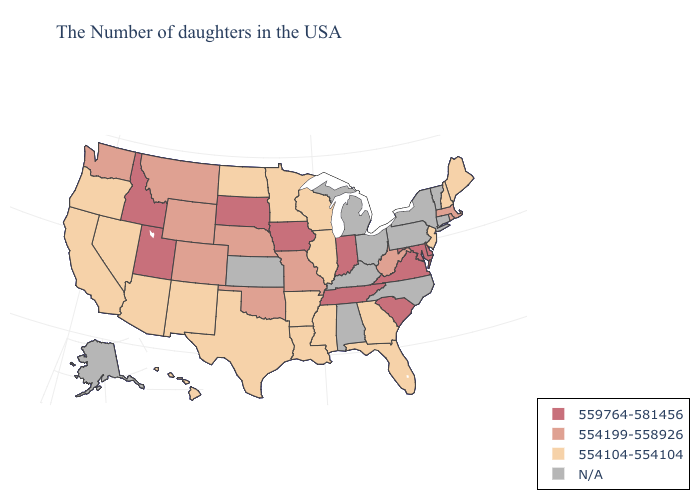Which states have the lowest value in the USA?
Be succinct. Maine, New Hampshire, New Jersey, Florida, Georgia, Wisconsin, Illinois, Mississippi, Louisiana, Arkansas, Minnesota, Texas, North Dakota, New Mexico, Arizona, Nevada, California, Oregon, Hawaii. Which states have the lowest value in the USA?
Quick response, please. Maine, New Hampshire, New Jersey, Florida, Georgia, Wisconsin, Illinois, Mississippi, Louisiana, Arkansas, Minnesota, Texas, North Dakota, New Mexico, Arizona, Nevada, California, Oregon, Hawaii. What is the value of South Dakota?
Keep it brief. 559764-581456. Does New Hampshire have the highest value in the Northeast?
Short answer required. No. Name the states that have a value in the range N/A?
Write a very short answer. Vermont, Connecticut, New York, Pennsylvania, North Carolina, Ohio, Michigan, Kentucky, Alabama, Kansas, Alaska. What is the highest value in states that border Utah?
Write a very short answer. 559764-581456. What is the value of Nebraska?
Concise answer only. 554199-558926. What is the highest value in states that border Connecticut?
Short answer required. 554199-558926. What is the value of North Carolina?
Answer briefly. N/A. Is the legend a continuous bar?
Be succinct. No. What is the value of Hawaii?
Give a very brief answer. 554104-554104. Which states have the lowest value in the West?
Give a very brief answer. New Mexico, Arizona, Nevada, California, Oregon, Hawaii. Name the states that have a value in the range N/A?
Be succinct. Vermont, Connecticut, New York, Pennsylvania, North Carolina, Ohio, Michigan, Kentucky, Alabama, Kansas, Alaska. What is the value of New York?
Give a very brief answer. N/A. What is the lowest value in the USA?
Quick response, please. 554104-554104. 